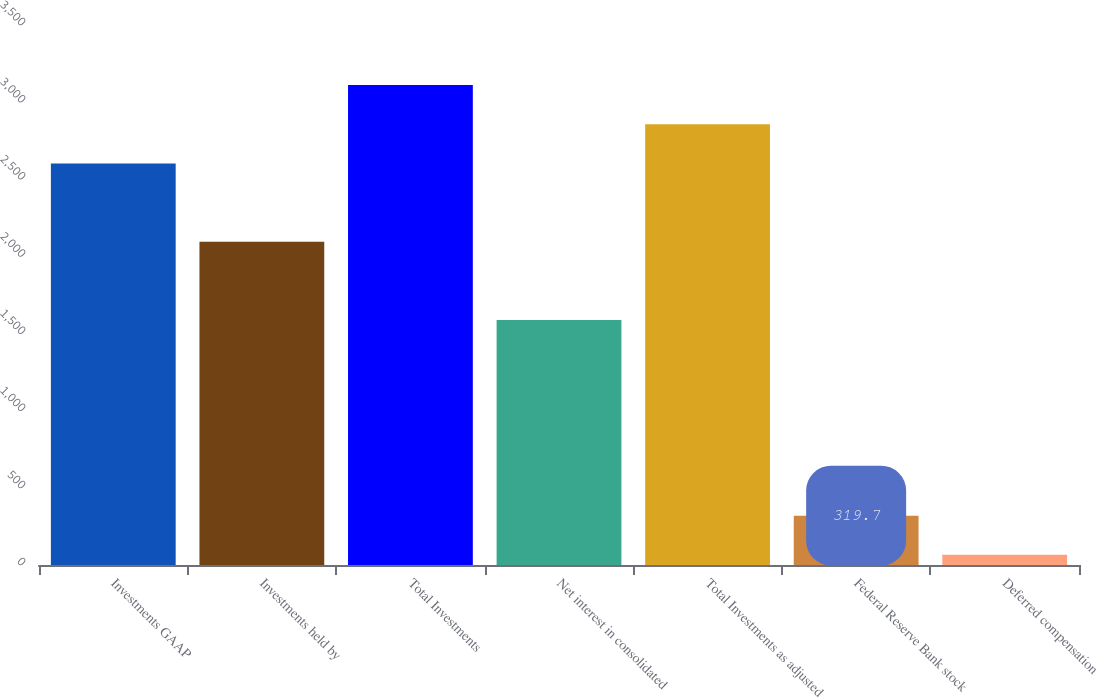<chart> <loc_0><loc_0><loc_500><loc_500><bar_chart><fcel>Investments GAAP<fcel>Investments held by<fcel>Total Investments<fcel>Net interest in consolidated<fcel>Total Investments as adjusted<fcel>Federal Reserve Bank stock<fcel>Deferred compensation<nl><fcel>2603<fcel>2095.6<fcel>3110.4<fcel>1588.2<fcel>2856.7<fcel>319.7<fcel>66<nl></chart> 